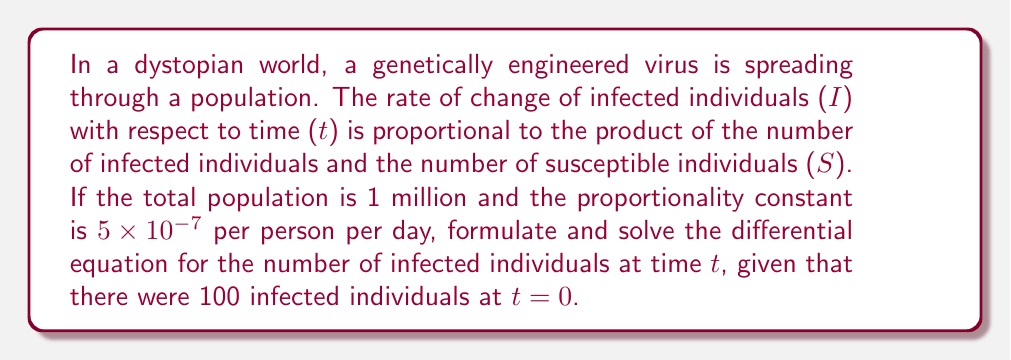What is the answer to this math problem? Let's approach this step-by-step:

1) First, we need to formulate the differential equation. Given that the rate of change of infected individuals is proportional to the product of infected and susceptible individuals, we can write:

   $$\frac{dI}{dt} = kIS$$

   where k is the proportionality constant.

2) We know that S + I = N, where N is the total population. So, S = N - I.

3) Substituting this into our equation:

   $$\frac{dI}{dt} = kI(N-I)$$

4) Now, let's plug in the given values:
   N = 1,000,000
   k = 5 × 10^(-7)

   $$\frac{dI}{dt} = 5 \times 10^{-7} \cdot I(1,000,000-I)$$

5) This can be simplified to:

   $$\frac{dI}{dt} = 0.5I(1000-I)$$

6) This is a separable differential equation. Let's separate the variables:

   $$\frac{dI}{I(1000-I)} = 0.5dt$$

7) Integrating both sides:

   $$\int \frac{dI}{I(1000-I)} = \int 0.5dt$$

8) The left side can be integrated using partial fractions:

   $$\frac{1}{1000}\ln|\frac{I}{1000-I}| = 0.5t + C$$

9) Using the initial condition I(0) = 100, we can solve for C:

   $$\frac{1}{1000}\ln|\frac{100}{900}| = C$$

   $$C = -0.002197$$

10) Therefore, the general solution is:

    $$\frac{1}{1000}\ln|\frac{I}{1000-I}| = 0.5t - 0.002197$$

11) Solving for I:

    $$I = \frac{1000}{1 + e^{-500t + 2.197}}$$

This is the logistic growth model, which is often used to model the spread of diseases.
Answer: $$I(t) = \frac{1000}{1 + e^{-500t + 2.197}}$$ 